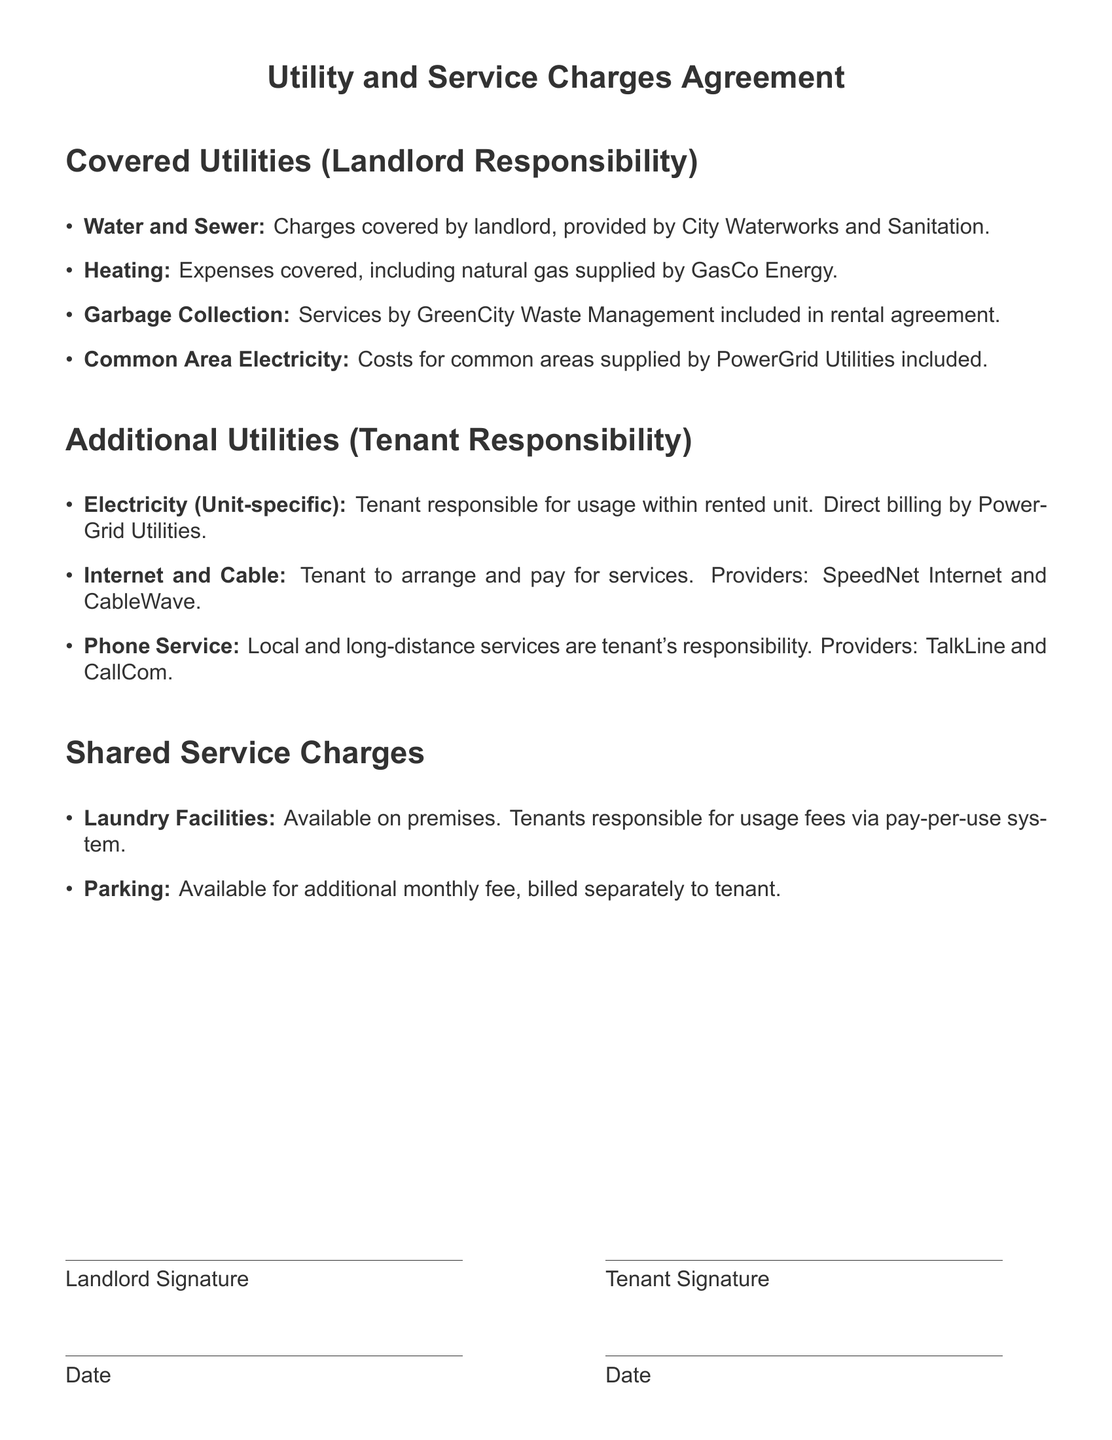What utilities are covered by the landlord? The document lists the utilities for which the landlord is responsible, including water, heating, garbage collection, and common area electricity.
Answer: Water and Sewer, Heating, Garbage Collection, Common Area Electricity Who is responsible for additional electricity charges? The document states that the tenant is responsible for the usage of electricity within their unit, with direct billing provided.
Answer: Tenant What service is provided for laundry facilities? The laundry facilities are available on the premises and are fee-based for tenants.
Answer: Pay-per-use system Which company supplies heating gas? The document specifies that natural gas for heating is supplied by a particular company.
Answer: GasCo Energy What is the tenant responsible for regarding phone service? According to the document, the tenant must arrange and pay for both local and long-distance phone services.
Answer: Tenant's responsibility What type of fee is associated with parking? The document indicates that parking incurs an additional charge, which is billed separately to the tenant.
Answer: Additional monthly fee Which company provides internet services? The document identifies the internet service provider that the tenant must arrange and pay for.
Answer: SpeedNet Internet Are common area electricity costs included in the rental agreement? The document confirms whether common area electricity costs are included, clarifying the landlord's responsibilities.
Answer: Included 